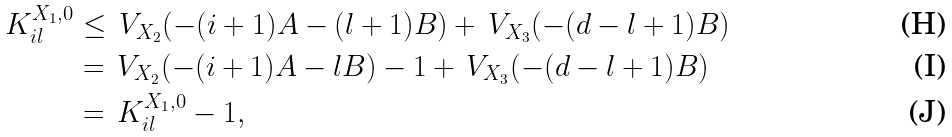<formula> <loc_0><loc_0><loc_500><loc_500>\, K _ { i l } ^ { X _ { 1 } , 0 } & \leq \, V _ { X _ { 2 } } ( - ( i + 1 ) A - ( l + 1 ) B ) + \, V _ { X _ { 3 } } ( - ( d - l + 1 ) B ) \\ & = \, V _ { X _ { 2 } } ( - ( i + 1 ) A - l B ) - 1 + \, V _ { X _ { 3 } } ( - ( d - l + 1 ) B ) \\ & = \, K _ { i l } ^ { X _ { 1 } , 0 } - 1 ,</formula> 